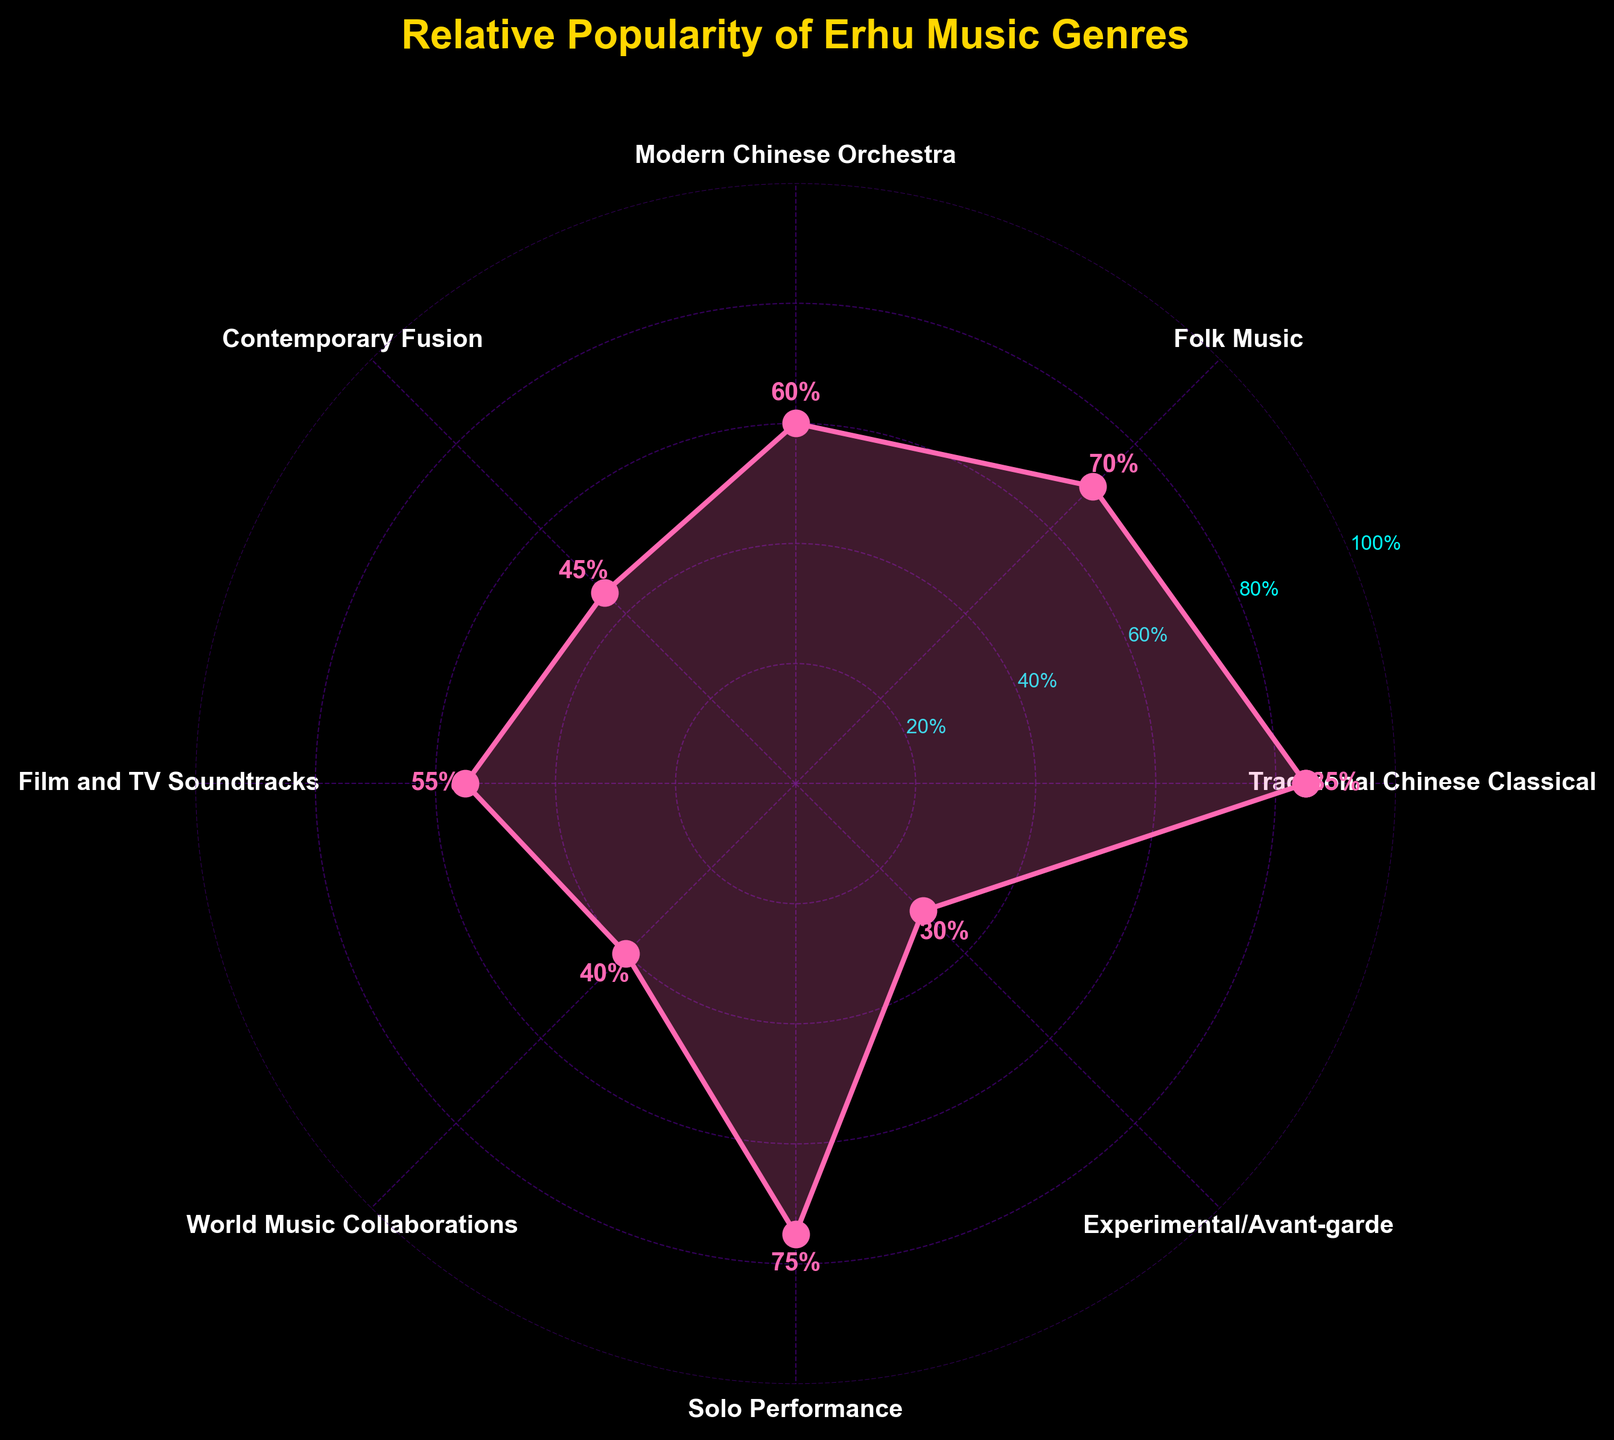What is the title of the figure? The title is usually displayed at the top of the figure. In this case, it reads 'Relative Popularity of Erhu Music Genres'.
Answer: Relative Popularity of Erhu Music Genres What color is used for the line connecting the data points? The line color can be seen as the one connecting all the data points in the radar plot. It's a pink color, which visually stands out.
Answer: Pink How many genres are displayed in the figure? Each genre is represented by a label around the radar plot, there are a total of 8 genres.
Answer: 8 What is the popularity value for 'Traditional Chinese Classical' music? The popularity value is directly indicated next to the 'Traditional Chinese Classical' label. It reads 85.
Answer: 85 Which genre has the lowest popularity? By looking at all the data points and their respective popularity values, 'Experimental/Avant-garde' has the lowest popularity with a value of 30.
Answer: Experimental/Avant-garde What is the difference in popularity between 'Solo Performance' and 'Contemporary Fusion'? The popularity values for 'Solo Performance' and 'Contemporary Fusion' are 75 and 45 respectively. The difference is calculated as 75 - 45.
Answer: 30 What is the average popularity of all the genres? Sum all the popularity values (85 + 70 + 60 + 45 + 55 + 40 + 75 + 30) which equals 460. Then divide by the number of genres which is 8. So, 460 / 8 = 57.5.
Answer: 57.5 Which genre's popularity is closest to 50%? By comparing all the values, 'Film and TV Soundtracks' has a popularity value of 55, which is the closest to 50%.
Answer: Film and TV Soundtracks Among the genres 'Folk Music' and 'World Music Collaborations', which is more popular? Comparing the popularity values of 'Folk Music' (70) and 'World Music Collaborations' (40), 'Folk Music' is more popular.
Answer: Folk Music Which genre experienced an average popularity, considering 100 as the maximum popularity? First, calculate the average popularity which we previously found to be 57.5. 'Modern Chinese Orchestra' with a popularity of 60 is the closest to this average.
Answer: Modern Chinese Orchestra 